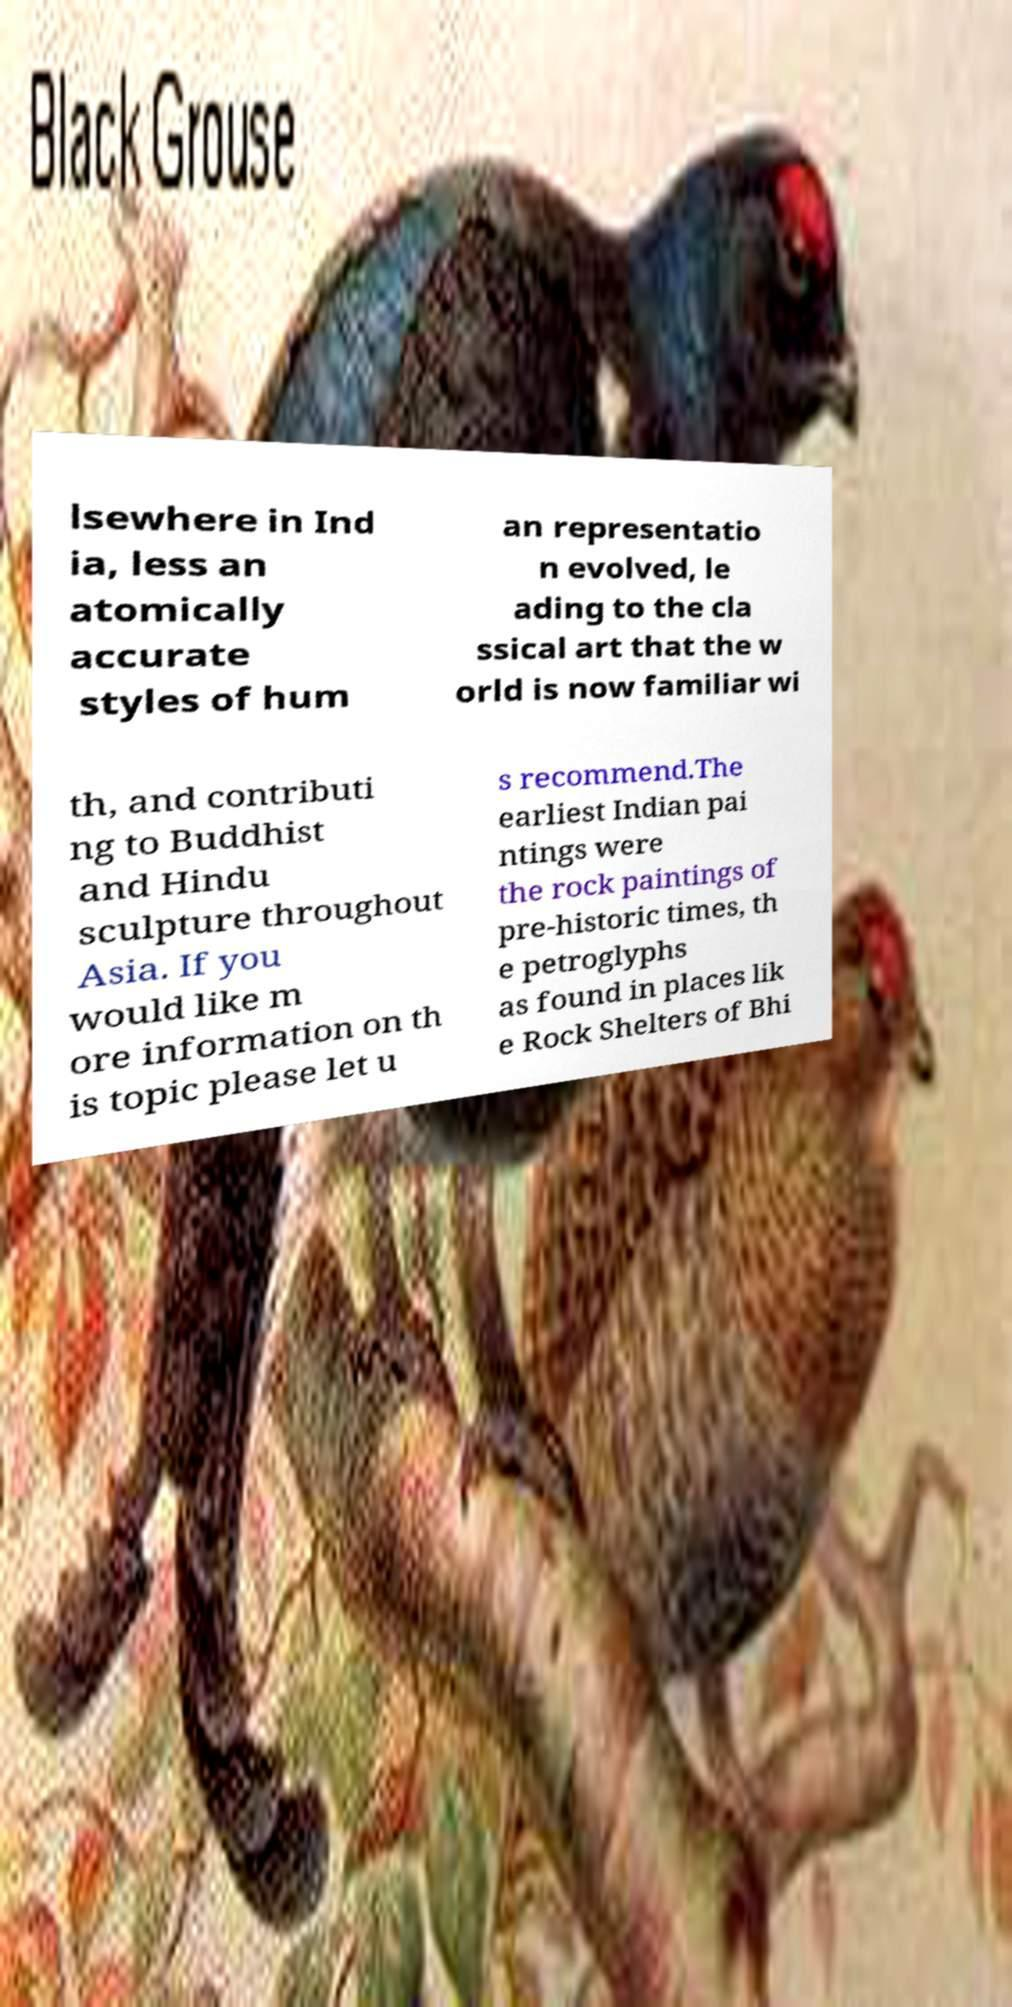Please identify and transcribe the text found in this image. lsewhere in Ind ia, less an atomically accurate styles of hum an representatio n evolved, le ading to the cla ssical art that the w orld is now familiar wi th, and contributi ng to Buddhist and Hindu sculpture throughout Asia. If you would like m ore information on th is topic please let u s recommend.The earliest Indian pai ntings were the rock paintings of pre-historic times, th e petroglyphs as found in places lik e Rock Shelters of Bhi 